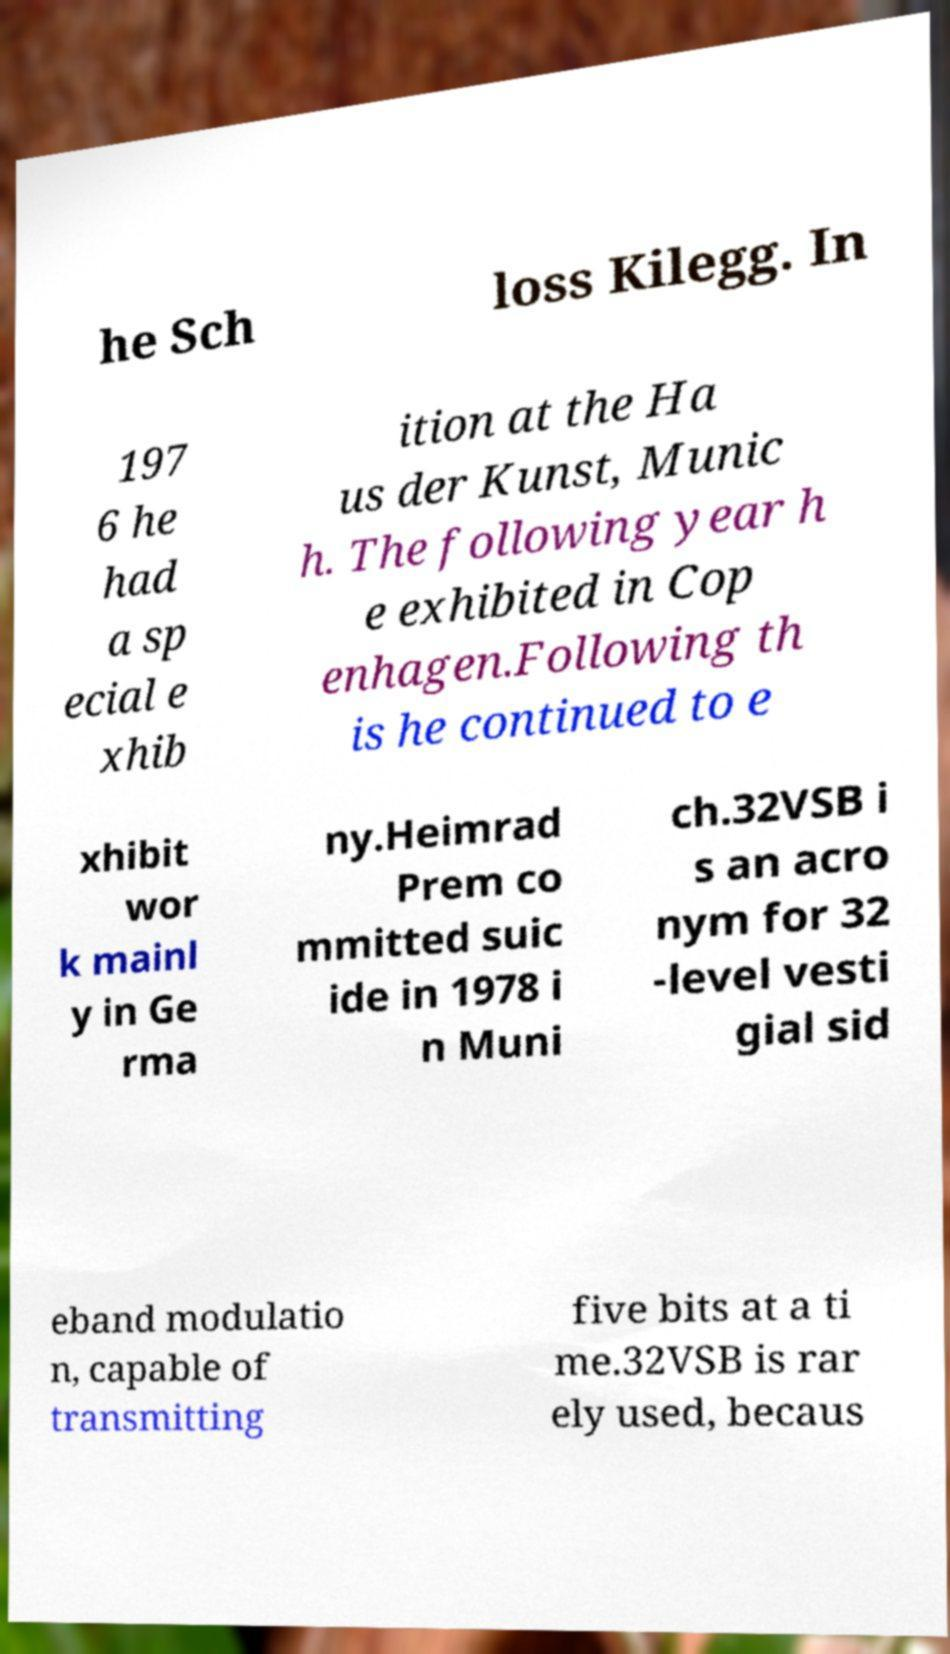There's text embedded in this image that I need extracted. Can you transcribe it verbatim? he Sch loss Kilegg. In 197 6 he had a sp ecial e xhib ition at the Ha us der Kunst, Munic h. The following year h e exhibited in Cop enhagen.Following th is he continued to e xhibit wor k mainl y in Ge rma ny.Heimrad Prem co mmitted suic ide in 1978 i n Muni ch.32VSB i s an acro nym for 32 -level vesti gial sid eband modulatio n, capable of transmitting five bits at a ti me.32VSB is rar ely used, becaus 